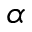Convert formula to latex. <formula><loc_0><loc_0><loc_500><loc_500>\alpha</formula> 